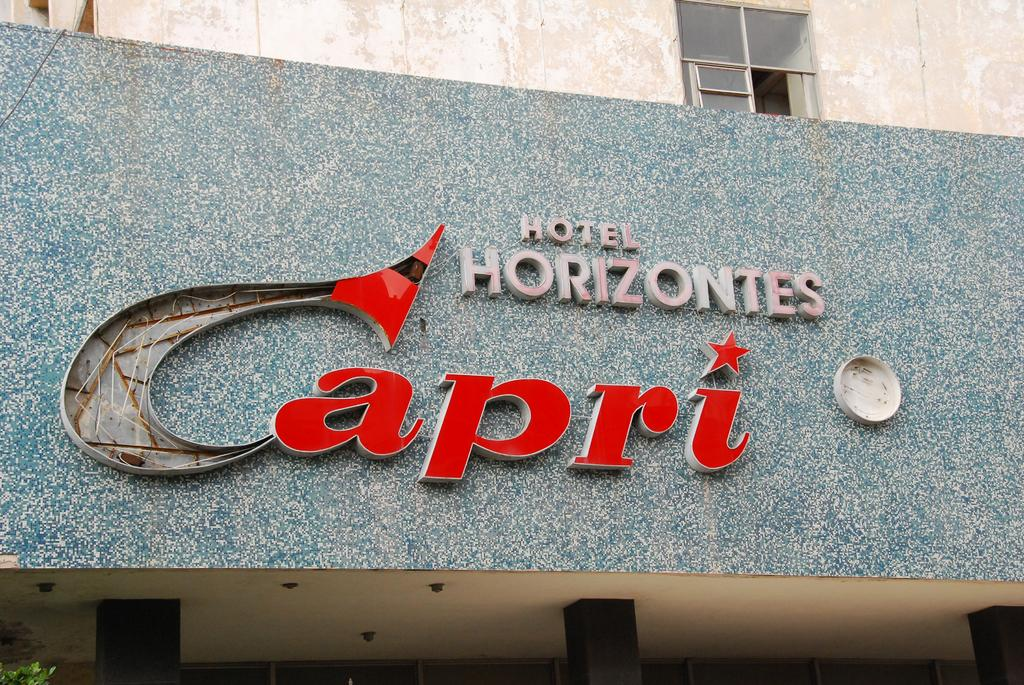<image>
Create a compact narrative representing the image presented. With a partially broken C the Hotel Capri sign looks like it needs repair. 